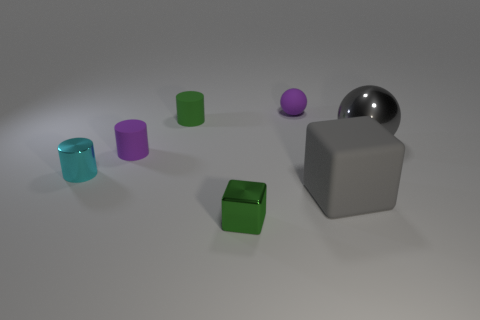How many other objects are there of the same color as the tiny ball?
Your answer should be compact. 1. Are the large gray thing that is behind the cyan metal cylinder and the purple sphere made of the same material?
Make the answer very short. No. What is the material of the small object that is the same shape as the large gray matte thing?
Your answer should be very brief. Metal. There is a block that is the same color as the metal sphere; what is it made of?
Provide a succinct answer. Rubber. Is the number of tiny balls less than the number of small green rubber balls?
Provide a short and direct response. No. Is the color of the big object that is behind the gray rubber block the same as the large rubber object?
Provide a short and direct response. Yes. The block that is the same material as the cyan cylinder is what color?
Offer a very short reply. Green. Is the size of the purple ball the same as the cyan cylinder?
Keep it short and to the point. Yes. What material is the large block?
Your response must be concise. Rubber. What material is the block that is the same size as the purple matte cylinder?
Your answer should be very brief. Metal. 